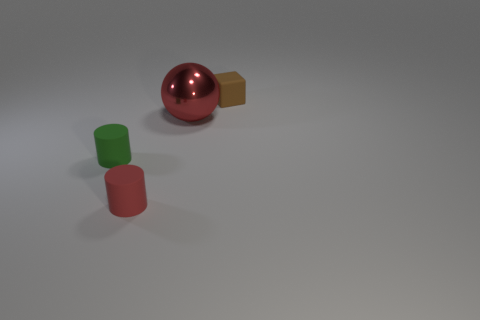There is a block that is the same size as the red matte cylinder; what color is it?
Offer a very short reply. Brown. There is a green rubber cylinder; what number of small brown matte objects are right of it?
Offer a very short reply. 1. Is there a cylinder?
Your answer should be compact. Yes. There is a red thing on the right side of the small matte cylinder that is in front of the small matte thing left of the red cylinder; what size is it?
Provide a short and direct response. Large. What number of other objects are the same size as the red metallic sphere?
Make the answer very short. 0. What is the size of the rubber thing in front of the tiny green object?
Your answer should be very brief. Small. Are there any other things that have the same color as the cube?
Make the answer very short. No. Is the object to the right of the metal ball made of the same material as the big ball?
Offer a terse response. No. What number of tiny matte things are in front of the ball and behind the large red sphere?
Your answer should be compact. 0. What size is the red object that is behind the tiny matte cylinder to the left of the red rubber cylinder?
Offer a terse response. Large. 